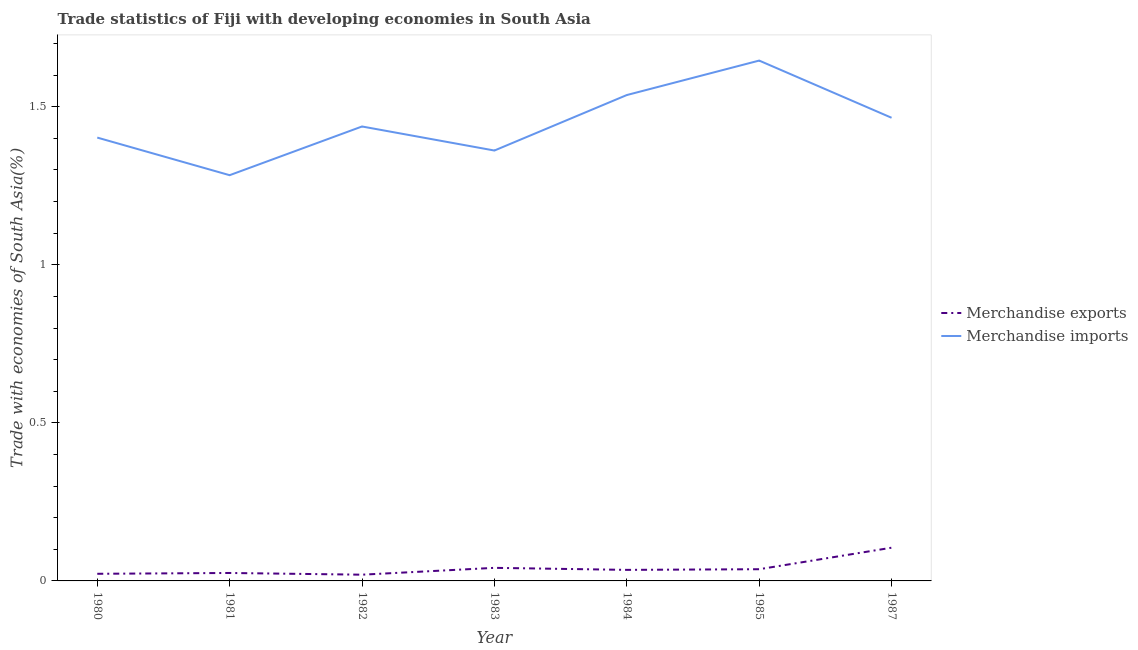Is the number of lines equal to the number of legend labels?
Provide a succinct answer. Yes. What is the merchandise imports in 1987?
Provide a short and direct response. 1.47. Across all years, what is the maximum merchandise imports?
Your answer should be compact. 1.65. Across all years, what is the minimum merchandise imports?
Offer a terse response. 1.28. In which year was the merchandise imports maximum?
Keep it short and to the point. 1985. What is the total merchandise exports in the graph?
Offer a very short reply. 0.29. What is the difference between the merchandise imports in 1981 and that in 1985?
Ensure brevity in your answer.  -0.36. What is the difference between the merchandise exports in 1987 and the merchandise imports in 1981?
Offer a terse response. -1.18. What is the average merchandise imports per year?
Offer a very short reply. 1.45. In the year 1982, what is the difference between the merchandise exports and merchandise imports?
Your answer should be very brief. -1.42. In how many years, is the merchandise exports greater than 0.5 %?
Give a very brief answer. 0. What is the ratio of the merchandise exports in 1980 to that in 1981?
Your answer should be compact. 0.9. Is the difference between the merchandise imports in 1981 and 1983 greater than the difference between the merchandise exports in 1981 and 1983?
Offer a terse response. No. What is the difference between the highest and the second highest merchandise imports?
Your answer should be very brief. 0.11. What is the difference between the highest and the lowest merchandise exports?
Provide a succinct answer. 0.09. How many lines are there?
Offer a very short reply. 2. How many years are there in the graph?
Provide a succinct answer. 7. Where does the legend appear in the graph?
Ensure brevity in your answer.  Center right. How are the legend labels stacked?
Your response must be concise. Vertical. What is the title of the graph?
Give a very brief answer. Trade statistics of Fiji with developing economies in South Asia. Does "International Tourists" appear as one of the legend labels in the graph?
Offer a very short reply. No. What is the label or title of the X-axis?
Give a very brief answer. Year. What is the label or title of the Y-axis?
Provide a short and direct response. Trade with economies of South Asia(%). What is the Trade with economies of South Asia(%) in Merchandise exports in 1980?
Offer a terse response. 0.02. What is the Trade with economies of South Asia(%) of Merchandise imports in 1980?
Keep it short and to the point. 1.4. What is the Trade with economies of South Asia(%) in Merchandise exports in 1981?
Your answer should be very brief. 0.03. What is the Trade with economies of South Asia(%) in Merchandise imports in 1981?
Offer a very short reply. 1.28. What is the Trade with economies of South Asia(%) in Merchandise exports in 1982?
Offer a terse response. 0.02. What is the Trade with economies of South Asia(%) of Merchandise imports in 1982?
Provide a short and direct response. 1.44. What is the Trade with economies of South Asia(%) in Merchandise exports in 1983?
Provide a short and direct response. 0.04. What is the Trade with economies of South Asia(%) of Merchandise imports in 1983?
Ensure brevity in your answer.  1.36. What is the Trade with economies of South Asia(%) of Merchandise exports in 1984?
Give a very brief answer. 0.03. What is the Trade with economies of South Asia(%) in Merchandise imports in 1984?
Ensure brevity in your answer.  1.54. What is the Trade with economies of South Asia(%) of Merchandise exports in 1985?
Offer a very short reply. 0.04. What is the Trade with economies of South Asia(%) of Merchandise imports in 1985?
Provide a succinct answer. 1.65. What is the Trade with economies of South Asia(%) in Merchandise exports in 1987?
Offer a terse response. 0.11. What is the Trade with economies of South Asia(%) of Merchandise imports in 1987?
Offer a very short reply. 1.47. Across all years, what is the maximum Trade with economies of South Asia(%) in Merchandise exports?
Provide a succinct answer. 0.11. Across all years, what is the maximum Trade with economies of South Asia(%) of Merchandise imports?
Ensure brevity in your answer.  1.65. Across all years, what is the minimum Trade with economies of South Asia(%) in Merchandise exports?
Your answer should be very brief. 0.02. Across all years, what is the minimum Trade with economies of South Asia(%) in Merchandise imports?
Provide a succinct answer. 1.28. What is the total Trade with economies of South Asia(%) in Merchandise exports in the graph?
Keep it short and to the point. 0.29. What is the total Trade with economies of South Asia(%) of Merchandise imports in the graph?
Your answer should be compact. 10.13. What is the difference between the Trade with economies of South Asia(%) of Merchandise exports in 1980 and that in 1981?
Give a very brief answer. -0. What is the difference between the Trade with economies of South Asia(%) of Merchandise imports in 1980 and that in 1981?
Your answer should be compact. 0.12. What is the difference between the Trade with economies of South Asia(%) in Merchandise exports in 1980 and that in 1982?
Keep it short and to the point. 0. What is the difference between the Trade with economies of South Asia(%) of Merchandise imports in 1980 and that in 1982?
Offer a very short reply. -0.04. What is the difference between the Trade with economies of South Asia(%) in Merchandise exports in 1980 and that in 1983?
Your answer should be very brief. -0.02. What is the difference between the Trade with economies of South Asia(%) in Merchandise imports in 1980 and that in 1983?
Offer a very short reply. 0.04. What is the difference between the Trade with economies of South Asia(%) in Merchandise exports in 1980 and that in 1984?
Keep it short and to the point. -0.01. What is the difference between the Trade with economies of South Asia(%) of Merchandise imports in 1980 and that in 1984?
Provide a short and direct response. -0.13. What is the difference between the Trade with economies of South Asia(%) in Merchandise exports in 1980 and that in 1985?
Provide a short and direct response. -0.01. What is the difference between the Trade with economies of South Asia(%) in Merchandise imports in 1980 and that in 1985?
Your answer should be compact. -0.24. What is the difference between the Trade with economies of South Asia(%) in Merchandise exports in 1980 and that in 1987?
Ensure brevity in your answer.  -0.08. What is the difference between the Trade with economies of South Asia(%) in Merchandise imports in 1980 and that in 1987?
Provide a short and direct response. -0.06. What is the difference between the Trade with economies of South Asia(%) in Merchandise exports in 1981 and that in 1982?
Make the answer very short. 0.01. What is the difference between the Trade with economies of South Asia(%) in Merchandise imports in 1981 and that in 1982?
Make the answer very short. -0.15. What is the difference between the Trade with economies of South Asia(%) of Merchandise exports in 1981 and that in 1983?
Provide a short and direct response. -0.02. What is the difference between the Trade with economies of South Asia(%) of Merchandise imports in 1981 and that in 1983?
Offer a terse response. -0.08. What is the difference between the Trade with economies of South Asia(%) in Merchandise exports in 1981 and that in 1984?
Ensure brevity in your answer.  -0.01. What is the difference between the Trade with economies of South Asia(%) of Merchandise imports in 1981 and that in 1984?
Keep it short and to the point. -0.25. What is the difference between the Trade with economies of South Asia(%) of Merchandise exports in 1981 and that in 1985?
Give a very brief answer. -0.01. What is the difference between the Trade with economies of South Asia(%) of Merchandise imports in 1981 and that in 1985?
Offer a very short reply. -0.36. What is the difference between the Trade with economies of South Asia(%) of Merchandise exports in 1981 and that in 1987?
Give a very brief answer. -0.08. What is the difference between the Trade with economies of South Asia(%) in Merchandise imports in 1981 and that in 1987?
Your answer should be compact. -0.18. What is the difference between the Trade with economies of South Asia(%) in Merchandise exports in 1982 and that in 1983?
Offer a terse response. -0.02. What is the difference between the Trade with economies of South Asia(%) of Merchandise imports in 1982 and that in 1983?
Your response must be concise. 0.08. What is the difference between the Trade with economies of South Asia(%) of Merchandise exports in 1982 and that in 1984?
Your answer should be very brief. -0.02. What is the difference between the Trade with economies of South Asia(%) of Merchandise imports in 1982 and that in 1984?
Your answer should be compact. -0.1. What is the difference between the Trade with economies of South Asia(%) of Merchandise exports in 1982 and that in 1985?
Keep it short and to the point. -0.02. What is the difference between the Trade with economies of South Asia(%) of Merchandise imports in 1982 and that in 1985?
Offer a terse response. -0.21. What is the difference between the Trade with economies of South Asia(%) in Merchandise exports in 1982 and that in 1987?
Provide a short and direct response. -0.09. What is the difference between the Trade with economies of South Asia(%) of Merchandise imports in 1982 and that in 1987?
Offer a terse response. -0.03. What is the difference between the Trade with economies of South Asia(%) in Merchandise exports in 1983 and that in 1984?
Provide a succinct answer. 0.01. What is the difference between the Trade with economies of South Asia(%) of Merchandise imports in 1983 and that in 1984?
Your answer should be very brief. -0.18. What is the difference between the Trade with economies of South Asia(%) of Merchandise exports in 1983 and that in 1985?
Offer a terse response. 0. What is the difference between the Trade with economies of South Asia(%) of Merchandise imports in 1983 and that in 1985?
Your response must be concise. -0.28. What is the difference between the Trade with economies of South Asia(%) in Merchandise exports in 1983 and that in 1987?
Keep it short and to the point. -0.06. What is the difference between the Trade with economies of South Asia(%) in Merchandise imports in 1983 and that in 1987?
Your answer should be compact. -0.1. What is the difference between the Trade with economies of South Asia(%) of Merchandise exports in 1984 and that in 1985?
Make the answer very short. -0. What is the difference between the Trade with economies of South Asia(%) of Merchandise imports in 1984 and that in 1985?
Provide a short and direct response. -0.11. What is the difference between the Trade with economies of South Asia(%) in Merchandise exports in 1984 and that in 1987?
Offer a very short reply. -0.07. What is the difference between the Trade with economies of South Asia(%) of Merchandise imports in 1984 and that in 1987?
Keep it short and to the point. 0.07. What is the difference between the Trade with economies of South Asia(%) in Merchandise exports in 1985 and that in 1987?
Ensure brevity in your answer.  -0.07. What is the difference between the Trade with economies of South Asia(%) of Merchandise imports in 1985 and that in 1987?
Keep it short and to the point. 0.18. What is the difference between the Trade with economies of South Asia(%) of Merchandise exports in 1980 and the Trade with economies of South Asia(%) of Merchandise imports in 1981?
Make the answer very short. -1.26. What is the difference between the Trade with economies of South Asia(%) in Merchandise exports in 1980 and the Trade with economies of South Asia(%) in Merchandise imports in 1982?
Make the answer very short. -1.42. What is the difference between the Trade with economies of South Asia(%) in Merchandise exports in 1980 and the Trade with economies of South Asia(%) in Merchandise imports in 1983?
Ensure brevity in your answer.  -1.34. What is the difference between the Trade with economies of South Asia(%) of Merchandise exports in 1980 and the Trade with economies of South Asia(%) of Merchandise imports in 1984?
Offer a terse response. -1.51. What is the difference between the Trade with economies of South Asia(%) of Merchandise exports in 1980 and the Trade with economies of South Asia(%) of Merchandise imports in 1985?
Your answer should be very brief. -1.62. What is the difference between the Trade with economies of South Asia(%) of Merchandise exports in 1980 and the Trade with economies of South Asia(%) of Merchandise imports in 1987?
Your answer should be very brief. -1.44. What is the difference between the Trade with economies of South Asia(%) in Merchandise exports in 1981 and the Trade with economies of South Asia(%) in Merchandise imports in 1982?
Give a very brief answer. -1.41. What is the difference between the Trade with economies of South Asia(%) of Merchandise exports in 1981 and the Trade with economies of South Asia(%) of Merchandise imports in 1983?
Offer a terse response. -1.34. What is the difference between the Trade with economies of South Asia(%) in Merchandise exports in 1981 and the Trade with economies of South Asia(%) in Merchandise imports in 1984?
Your response must be concise. -1.51. What is the difference between the Trade with economies of South Asia(%) of Merchandise exports in 1981 and the Trade with economies of South Asia(%) of Merchandise imports in 1985?
Provide a short and direct response. -1.62. What is the difference between the Trade with economies of South Asia(%) of Merchandise exports in 1981 and the Trade with economies of South Asia(%) of Merchandise imports in 1987?
Provide a succinct answer. -1.44. What is the difference between the Trade with economies of South Asia(%) of Merchandise exports in 1982 and the Trade with economies of South Asia(%) of Merchandise imports in 1983?
Give a very brief answer. -1.34. What is the difference between the Trade with economies of South Asia(%) of Merchandise exports in 1982 and the Trade with economies of South Asia(%) of Merchandise imports in 1984?
Your response must be concise. -1.52. What is the difference between the Trade with economies of South Asia(%) in Merchandise exports in 1982 and the Trade with economies of South Asia(%) in Merchandise imports in 1985?
Your response must be concise. -1.63. What is the difference between the Trade with economies of South Asia(%) in Merchandise exports in 1982 and the Trade with economies of South Asia(%) in Merchandise imports in 1987?
Provide a succinct answer. -1.45. What is the difference between the Trade with economies of South Asia(%) of Merchandise exports in 1983 and the Trade with economies of South Asia(%) of Merchandise imports in 1984?
Make the answer very short. -1.5. What is the difference between the Trade with economies of South Asia(%) of Merchandise exports in 1983 and the Trade with economies of South Asia(%) of Merchandise imports in 1985?
Your answer should be very brief. -1.6. What is the difference between the Trade with economies of South Asia(%) of Merchandise exports in 1983 and the Trade with economies of South Asia(%) of Merchandise imports in 1987?
Offer a terse response. -1.42. What is the difference between the Trade with economies of South Asia(%) of Merchandise exports in 1984 and the Trade with economies of South Asia(%) of Merchandise imports in 1985?
Make the answer very short. -1.61. What is the difference between the Trade with economies of South Asia(%) in Merchandise exports in 1984 and the Trade with economies of South Asia(%) in Merchandise imports in 1987?
Keep it short and to the point. -1.43. What is the difference between the Trade with economies of South Asia(%) in Merchandise exports in 1985 and the Trade with economies of South Asia(%) in Merchandise imports in 1987?
Offer a very short reply. -1.43. What is the average Trade with economies of South Asia(%) in Merchandise exports per year?
Provide a succinct answer. 0.04. What is the average Trade with economies of South Asia(%) in Merchandise imports per year?
Offer a very short reply. 1.45. In the year 1980, what is the difference between the Trade with economies of South Asia(%) in Merchandise exports and Trade with economies of South Asia(%) in Merchandise imports?
Ensure brevity in your answer.  -1.38. In the year 1981, what is the difference between the Trade with economies of South Asia(%) of Merchandise exports and Trade with economies of South Asia(%) of Merchandise imports?
Provide a succinct answer. -1.26. In the year 1982, what is the difference between the Trade with economies of South Asia(%) in Merchandise exports and Trade with economies of South Asia(%) in Merchandise imports?
Make the answer very short. -1.42. In the year 1983, what is the difference between the Trade with economies of South Asia(%) in Merchandise exports and Trade with economies of South Asia(%) in Merchandise imports?
Your answer should be very brief. -1.32. In the year 1984, what is the difference between the Trade with economies of South Asia(%) in Merchandise exports and Trade with economies of South Asia(%) in Merchandise imports?
Provide a succinct answer. -1.5. In the year 1985, what is the difference between the Trade with economies of South Asia(%) of Merchandise exports and Trade with economies of South Asia(%) of Merchandise imports?
Provide a short and direct response. -1.61. In the year 1987, what is the difference between the Trade with economies of South Asia(%) of Merchandise exports and Trade with economies of South Asia(%) of Merchandise imports?
Give a very brief answer. -1.36. What is the ratio of the Trade with economies of South Asia(%) in Merchandise exports in 1980 to that in 1981?
Provide a short and direct response. 0.9. What is the ratio of the Trade with economies of South Asia(%) in Merchandise imports in 1980 to that in 1981?
Your answer should be compact. 1.09. What is the ratio of the Trade with economies of South Asia(%) in Merchandise exports in 1980 to that in 1982?
Ensure brevity in your answer.  1.14. What is the ratio of the Trade with economies of South Asia(%) of Merchandise imports in 1980 to that in 1982?
Make the answer very short. 0.98. What is the ratio of the Trade with economies of South Asia(%) of Merchandise exports in 1980 to that in 1983?
Give a very brief answer. 0.55. What is the ratio of the Trade with economies of South Asia(%) of Merchandise imports in 1980 to that in 1983?
Provide a succinct answer. 1.03. What is the ratio of the Trade with economies of South Asia(%) in Merchandise exports in 1980 to that in 1984?
Provide a succinct answer. 0.65. What is the ratio of the Trade with economies of South Asia(%) in Merchandise imports in 1980 to that in 1984?
Offer a terse response. 0.91. What is the ratio of the Trade with economies of South Asia(%) of Merchandise exports in 1980 to that in 1985?
Offer a very short reply. 0.61. What is the ratio of the Trade with economies of South Asia(%) of Merchandise imports in 1980 to that in 1985?
Your response must be concise. 0.85. What is the ratio of the Trade with economies of South Asia(%) in Merchandise exports in 1980 to that in 1987?
Your answer should be very brief. 0.21. What is the ratio of the Trade with economies of South Asia(%) in Merchandise imports in 1980 to that in 1987?
Provide a short and direct response. 0.96. What is the ratio of the Trade with economies of South Asia(%) of Merchandise exports in 1981 to that in 1982?
Provide a short and direct response. 1.28. What is the ratio of the Trade with economies of South Asia(%) in Merchandise imports in 1981 to that in 1982?
Provide a succinct answer. 0.89. What is the ratio of the Trade with economies of South Asia(%) of Merchandise exports in 1981 to that in 1983?
Offer a terse response. 0.61. What is the ratio of the Trade with economies of South Asia(%) in Merchandise imports in 1981 to that in 1983?
Offer a very short reply. 0.94. What is the ratio of the Trade with economies of South Asia(%) in Merchandise exports in 1981 to that in 1984?
Keep it short and to the point. 0.72. What is the ratio of the Trade with economies of South Asia(%) in Merchandise imports in 1981 to that in 1984?
Provide a succinct answer. 0.84. What is the ratio of the Trade with economies of South Asia(%) in Merchandise exports in 1981 to that in 1985?
Your response must be concise. 0.68. What is the ratio of the Trade with economies of South Asia(%) of Merchandise imports in 1981 to that in 1985?
Provide a succinct answer. 0.78. What is the ratio of the Trade with economies of South Asia(%) in Merchandise exports in 1981 to that in 1987?
Keep it short and to the point. 0.24. What is the ratio of the Trade with economies of South Asia(%) in Merchandise imports in 1981 to that in 1987?
Offer a very short reply. 0.88. What is the ratio of the Trade with economies of South Asia(%) in Merchandise exports in 1982 to that in 1983?
Offer a very short reply. 0.48. What is the ratio of the Trade with economies of South Asia(%) of Merchandise imports in 1982 to that in 1983?
Give a very brief answer. 1.06. What is the ratio of the Trade with economies of South Asia(%) in Merchandise exports in 1982 to that in 1984?
Make the answer very short. 0.56. What is the ratio of the Trade with economies of South Asia(%) of Merchandise imports in 1982 to that in 1984?
Provide a succinct answer. 0.94. What is the ratio of the Trade with economies of South Asia(%) of Merchandise exports in 1982 to that in 1985?
Offer a terse response. 0.53. What is the ratio of the Trade with economies of South Asia(%) in Merchandise imports in 1982 to that in 1985?
Provide a short and direct response. 0.87. What is the ratio of the Trade with economies of South Asia(%) of Merchandise exports in 1982 to that in 1987?
Offer a terse response. 0.19. What is the ratio of the Trade with economies of South Asia(%) of Merchandise imports in 1982 to that in 1987?
Your answer should be very brief. 0.98. What is the ratio of the Trade with economies of South Asia(%) in Merchandise exports in 1983 to that in 1984?
Ensure brevity in your answer.  1.18. What is the ratio of the Trade with economies of South Asia(%) of Merchandise imports in 1983 to that in 1984?
Your answer should be very brief. 0.89. What is the ratio of the Trade with economies of South Asia(%) in Merchandise exports in 1983 to that in 1985?
Provide a succinct answer. 1.12. What is the ratio of the Trade with economies of South Asia(%) of Merchandise imports in 1983 to that in 1985?
Offer a very short reply. 0.83. What is the ratio of the Trade with economies of South Asia(%) of Merchandise exports in 1983 to that in 1987?
Make the answer very short. 0.39. What is the ratio of the Trade with economies of South Asia(%) of Merchandise imports in 1983 to that in 1987?
Keep it short and to the point. 0.93. What is the ratio of the Trade with economies of South Asia(%) in Merchandise exports in 1984 to that in 1985?
Offer a very short reply. 0.94. What is the ratio of the Trade with economies of South Asia(%) in Merchandise imports in 1984 to that in 1985?
Your response must be concise. 0.93. What is the ratio of the Trade with economies of South Asia(%) in Merchandise exports in 1984 to that in 1987?
Provide a succinct answer. 0.33. What is the ratio of the Trade with economies of South Asia(%) in Merchandise imports in 1984 to that in 1987?
Your response must be concise. 1.05. What is the ratio of the Trade with economies of South Asia(%) in Merchandise exports in 1985 to that in 1987?
Ensure brevity in your answer.  0.35. What is the ratio of the Trade with economies of South Asia(%) in Merchandise imports in 1985 to that in 1987?
Keep it short and to the point. 1.12. What is the difference between the highest and the second highest Trade with economies of South Asia(%) in Merchandise exports?
Ensure brevity in your answer.  0.06. What is the difference between the highest and the second highest Trade with economies of South Asia(%) of Merchandise imports?
Keep it short and to the point. 0.11. What is the difference between the highest and the lowest Trade with economies of South Asia(%) in Merchandise exports?
Offer a terse response. 0.09. What is the difference between the highest and the lowest Trade with economies of South Asia(%) of Merchandise imports?
Your answer should be compact. 0.36. 